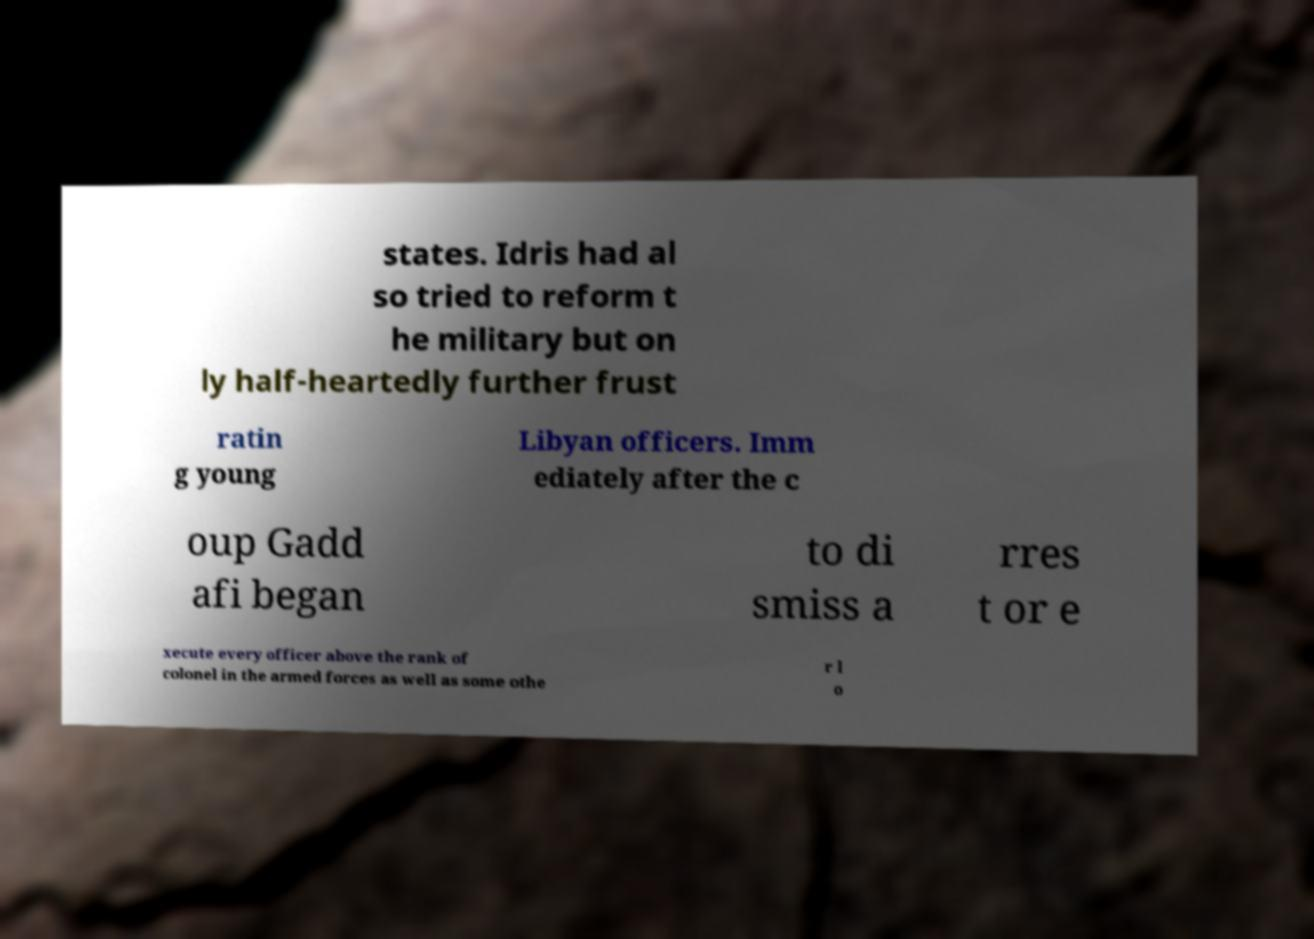Please read and relay the text visible in this image. What does it say? states. Idris had al so tried to reform t he military but on ly half-heartedly further frust ratin g young Libyan officers. Imm ediately after the c oup Gadd afi began to di smiss a rres t or e xecute every officer above the rank of colonel in the armed forces as well as some othe r l o 